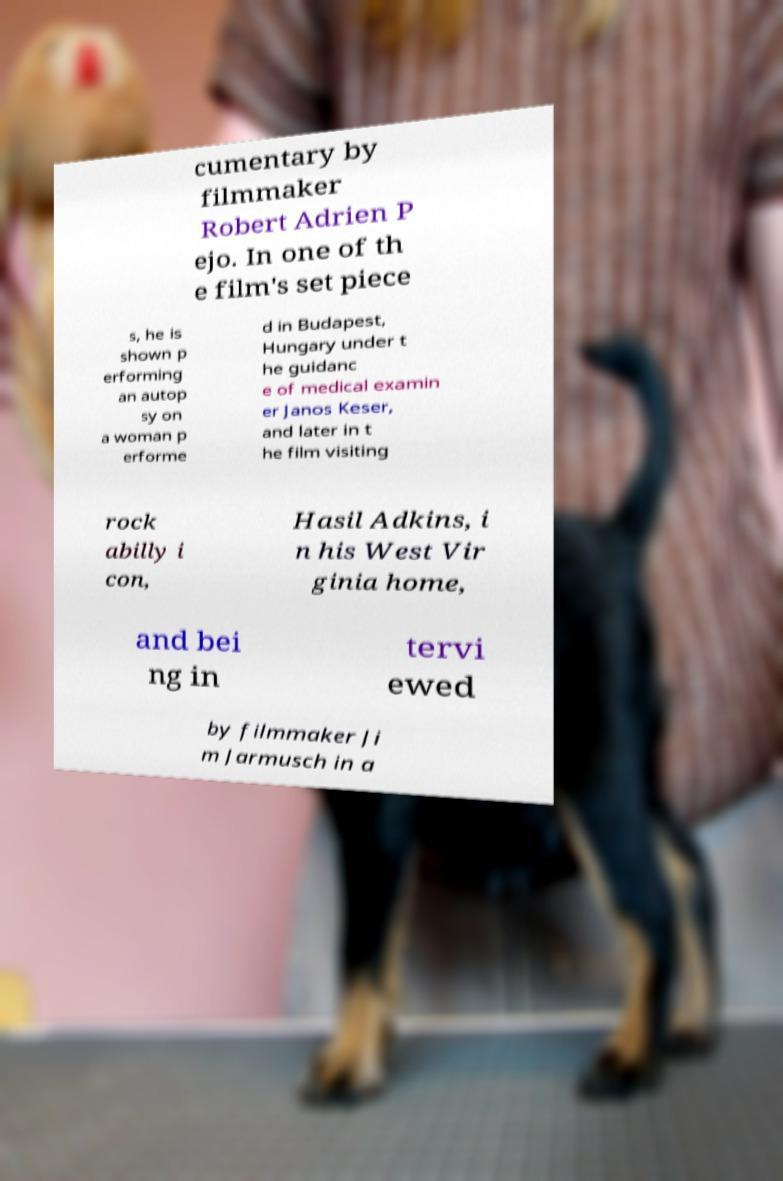Could you extract and type out the text from this image? cumentary by filmmaker Robert Adrien P ejo. In one of th e film's set piece s, he is shown p erforming an autop sy on a woman p erforme d in Budapest, Hungary under t he guidanc e of medical examin er Janos Keser, and later in t he film visiting rock abilly i con, Hasil Adkins, i n his West Vir ginia home, and bei ng in tervi ewed by filmmaker Ji m Jarmusch in a 